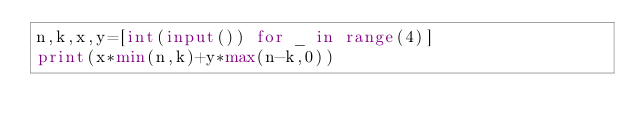<code> <loc_0><loc_0><loc_500><loc_500><_Python_>n,k,x,y=[int(input()) for _ in range(4)]
print(x*min(n,k)+y*max(n-k,0))
</code> 